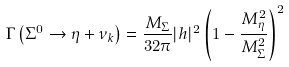Convert formula to latex. <formula><loc_0><loc_0><loc_500><loc_500>\Gamma \left ( \Sigma ^ { 0 } \rightarrow \eta + \nu _ { k } \right ) = \frac { M _ { \Sigma } } { 3 2 \pi } | h | ^ { 2 } \left ( 1 - \frac { M ^ { 2 } _ { \eta } } { M ^ { 2 } _ { \Sigma } } \right ) ^ { 2 }</formula> 